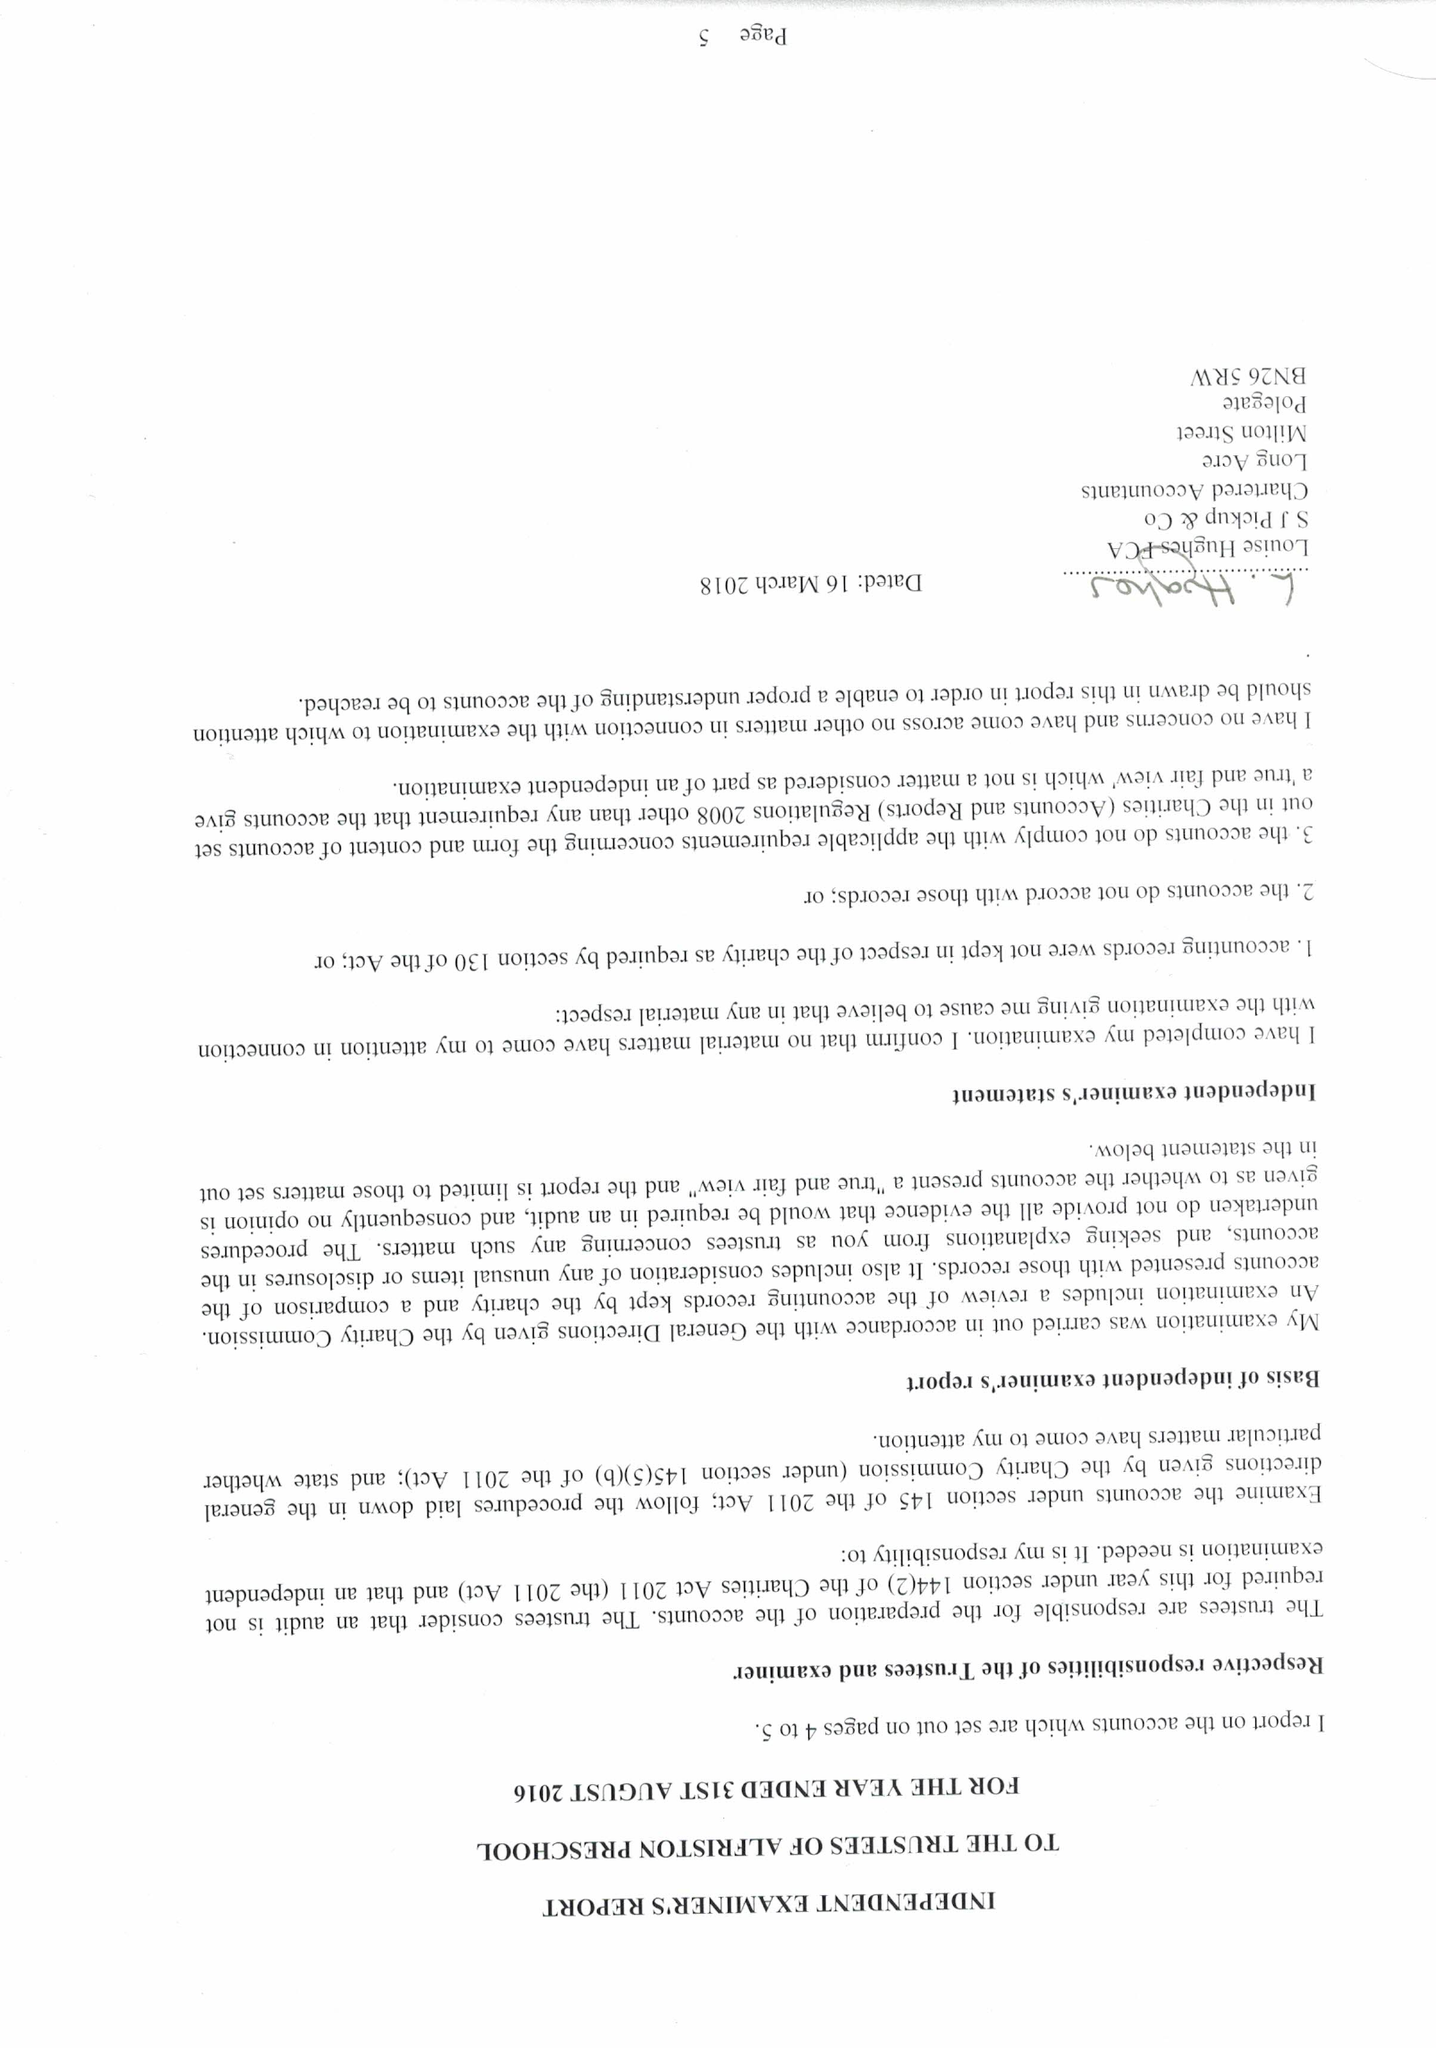What is the value for the charity_name?
Answer the question using a single word or phrase. Alfriston Pre-School 